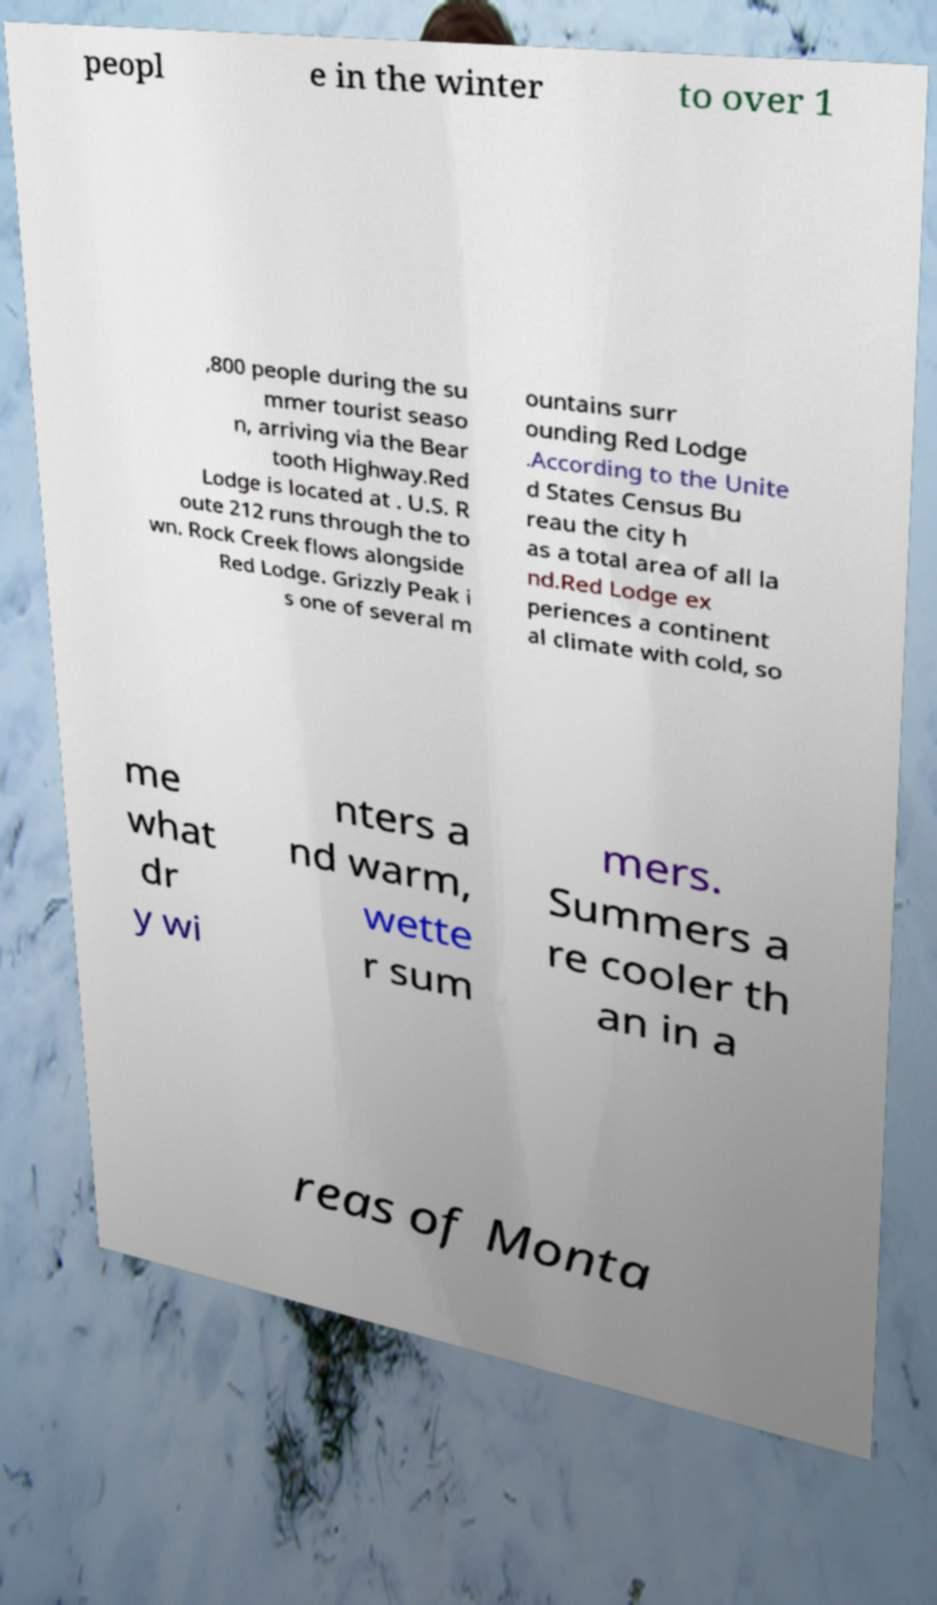There's text embedded in this image that I need extracted. Can you transcribe it verbatim? peopl e in the winter to over 1 ,800 people during the su mmer tourist seaso n, arriving via the Bear tooth Highway.Red Lodge is located at . U.S. R oute 212 runs through the to wn. Rock Creek flows alongside Red Lodge. Grizzly Peak i s one of several m ountains surr ounding Red Lodge .According to the Unite d States Census Bu reau the city h as a total area of all la nd.Red Lodge ex periences a continent al climate with cold, so me what dr y wi nters a nd warm, wette r sum mers. Summers a re cooler th an in a reas of Monta 